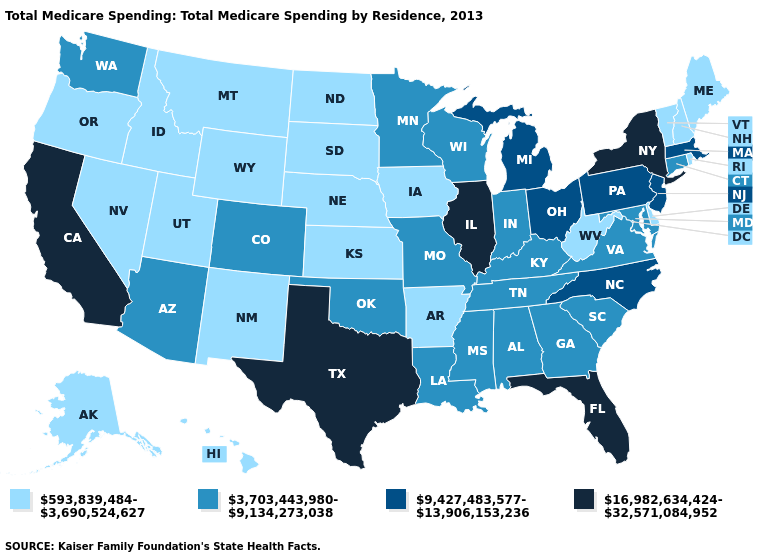Among the states that border New Jersey , which have the lowest value?
Answer briefly. Delaware. Which states have the lowest value in the Northeast?
Give a very brief answer. Maine, New Hampshire, Rhode Island, Vermont. Does the map have missing data?
Short answer required. No. Which states hav the highest value in the Northeast?
Give a very brief answer. New York. Name the states that have a value in the range 16,982,634,424-32,571,084,952?
Give a very brief answer. California, Florida, Illinois, New York, Texas. Does New Jersey have the same value as Louisiana?
Write a very short answer. No. Name the states that have a value in the range 593,839,484-3,690,524,627?
Keep it brief. Alaska, Arkansas, Delaware, Hawaii, Idaho, Iowa, Kansas, Maine, Montana, Nebraska, Nevada, New Hampshire, New Mexico, North Dakota, Oregon, Rhode Island, South Dakota, Utah, Vermont, West Virginia, Wyoming. Name the states that have a value in the range 3,703,443,980-9,134,273,038?
Short answer required. Alabama, Arizona, Colorado, Connecticut, Georgia, Indiana, Kentucky, Louisiana, Maryland, Minnesota, Mississippi, Missouri, Oklahoma, South Carolina, Tennessee, Virginia, Washington, Wisconsin. What is the value of Wisconsin?
Concise answer only. 3,703,443,980-9,134,273,038. Does Illinois have the highest value in the MidWest?
Be succinct. Yes. Name the states that have a value in the range 593,839,484-3,690,524,627?
Short answer required. Alaska, Arkansas, Delaware, Hawaii, Idaho, Iowa, Kansas, Maine, Montana, Nebraska, Nevada, New Hampshire, New Mexico, North Dakota, Oregon, Rhode Island, South Dakota, Utah, Vermont, West Virginia, Wyoming. Does California have the highest value in the USA?
Quick response, please. Yes. What is the value of Arizona?
Short answer required. 3,703,443,980-9,134,273,038. Which states have the highest value in the USA?
Quick response, please. California, Florida, Illinois, New York, Texas. Does Tennessee have a higher value than Alaska?
Write a very short answer. Yes. 